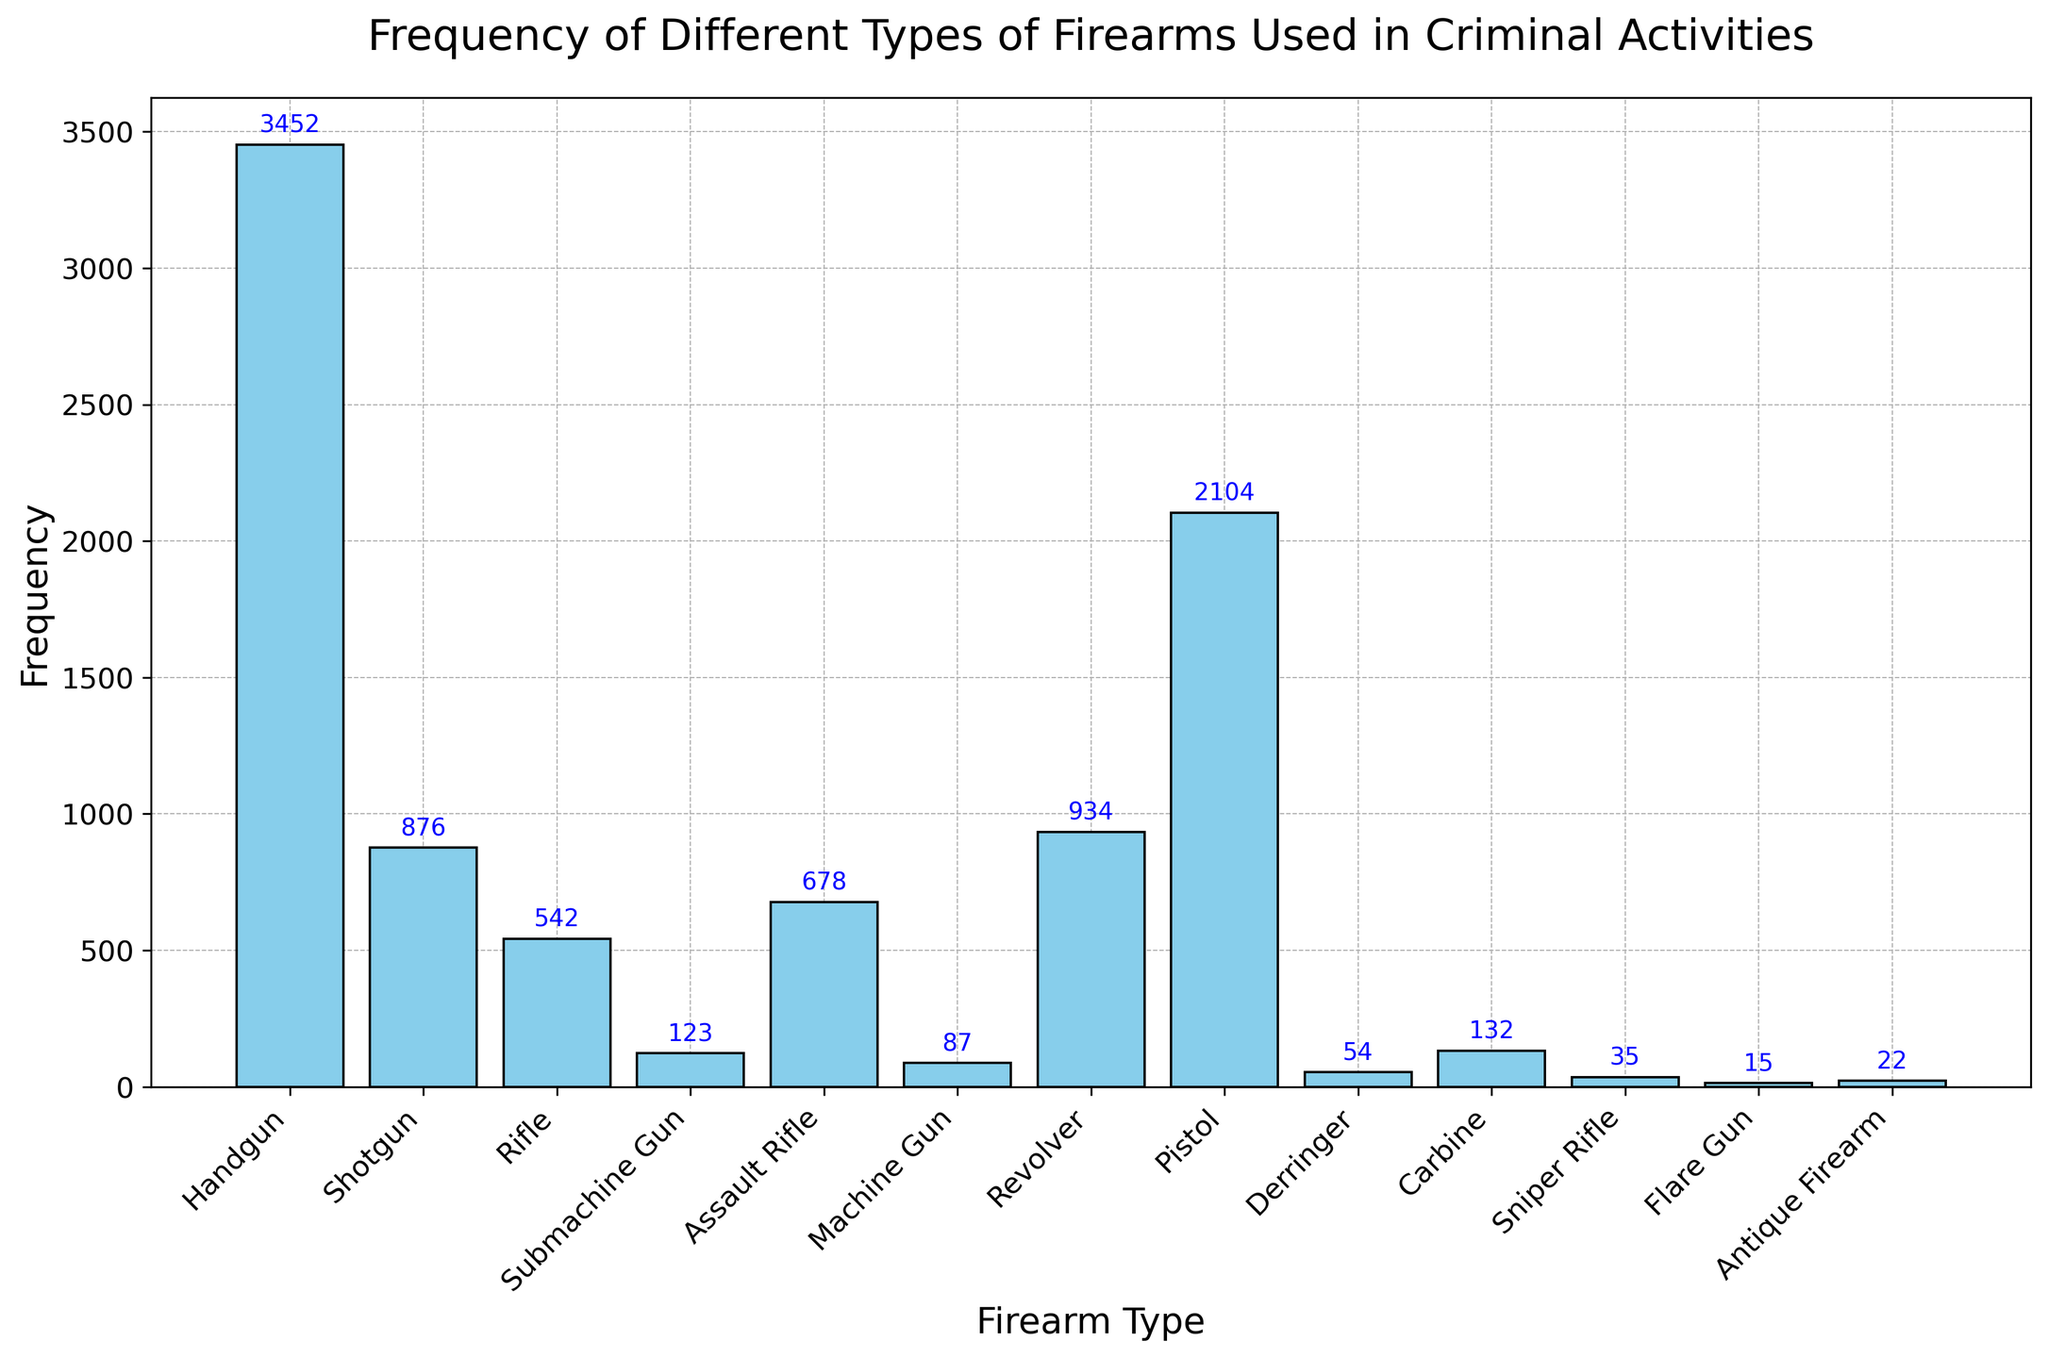Which firearm type has the highest frequency? The bar for Handgun is the highest among all bars in the chart.
Answer: Handgun What is the total frequency of all Assault Rifle types (Assault Rifle and Carbine)? Sum the frequencies of Assault Rifle and Carbine: 678 (Assault Rifle) + 132 (Carbine) = 810
Answer: 810 Which firearm type has a frequency closest to 100? Compare the frequencies close to 100: Derringer (54) and Machine Gun (87) are the closest ones. Machine Gun is closest to 100.
Answer: Machine Gun How does the frequency of Revolver compare to Pistol? Compare the heights of the Revolver and Pistol bars. Revolver has a frequency of 934, while Pistol has a frequency of 2104. Pistol has a higher frequency than Revolver.
Answer: Pistol has a higher frequency Which firearm types have a frequency less than 100? Identify the bars with heights less than 100: Derringer (54), Sniper Rifle (35), Flare Gun (15), and Antique Firearm (22).
Answer: Derringer, Sniper Rifle, Flare Gun, Antique Firearm What is the difference in frequency between Handgun and Shotgun? Subtract the frequency of Shotgun from Handgun: 3452 (Handgun) - 876 (Shotgun) = 2576
Answer: 2576 What is the average frequency of Rifle, Submachine Gun, and Antique Firearm? Sum the frequencies of Rifle, Submachine Gun, and Antique Firearm: 542 (Rifle) + 123 (Submachine Gun) + 22 (Antique Firearm) = 687. Divide by 3 to get the average: 687 / 3 = 229
Answer: 229 Which firearm type(s) have frequencies between 500 and 1000? Identify the bars with heights in the range 500-1000: Shotgun (876), Rifle (542), and Assault Rifle (678).
Answer: Shotgun, Rifle, Assault Rifle What is the sum of frequencies for all firearm types shown in the chart? Sum the frequencies of all firearm types: 3452 (Handgun) + 876 (Shotgun) + 542 (Rifle) + 123 (Submachine Gun) + 678 (Assault Rifle) + 87 (Machine Gun) + 934 (Revolver) + 2104 (Pistol) + 54 (Derringer) + 132 (Carbine) + 35 (Sniper Rifle) + 15 (Flare Gun) + 22 (Antique Firearm) = 9054
Answer: 9054 